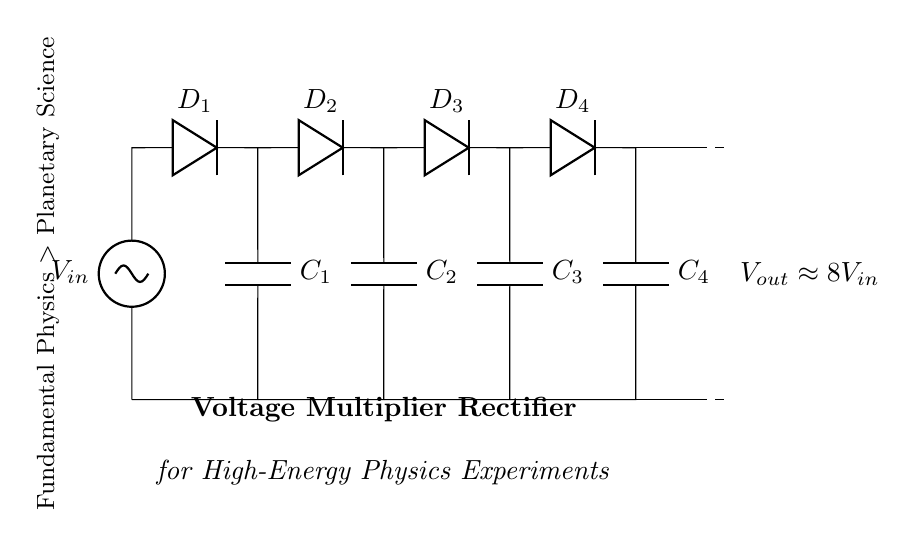What is the input voltage of the circuit? The input voltage, labeled as V in the circuit diagram, is shown at the leftmost part of the circuit.
Answer: V in How many diodes are present in the circuit? The circuit diagram clearly displays four diodes labeled D1, D2, D3, and D4 in series with the capacitors.
Answer: Four What is the approximate output voltage of this rectifier? The circuit indicates that the output voltage V out is approximately eight times the input voltage as labeled in the circuit.
Answer: Eight times V in Which components function as energy storage in this circuit? The energy storage components in the circuit are the capacitors, labeled C1, C2, C3, and C4, situated parallel to the diodes.
Answer: C1, C2, C3, C4 What is the function of the diodes in this voltage multiplier rectifier? The diodes direct the current flow in one direction, preventing backflow in order to charge the capacitors and increase the voltage output.
Answer: Convert AC to DC and prevent backflow How does the voltage multiplication occur in this circuit? The voltage multiplication occurs through a series arrangement of diodes and capacitors. Each stage effectively doubles the voltage by charging the capacitors to a higher potential during each cycle of the input AC voltage.
Answer: Via diodes and capacitors What role does this circuit type play in high-energy physics experiments? This voltage multiplier rectifier is crucial in high-energy physics experiments by providing a high DC voltage from a lower AC input, which is often necessary for particle detectors and accelerators.
Answer: High DC voltage supply 